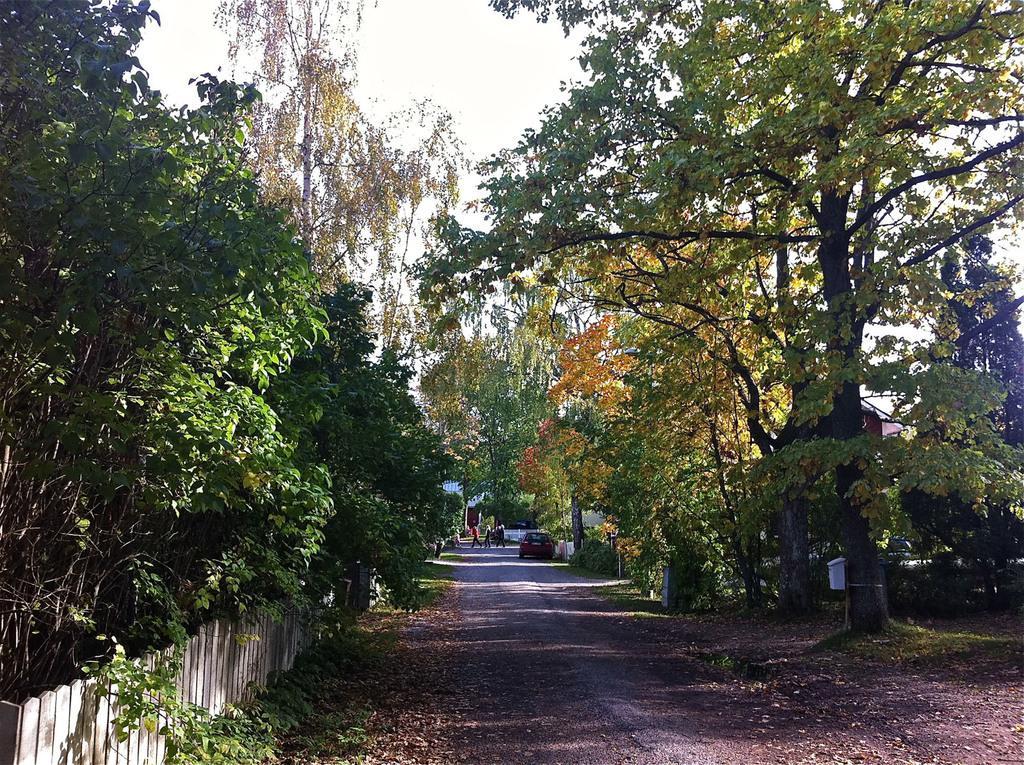Please provide a concise description of this image. As we can see in the image there are trees, wooden wall, car, group of people, plants and at the top there is sky. 